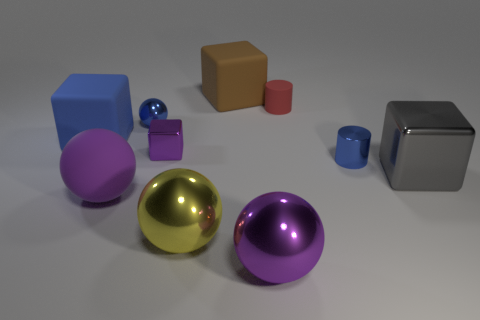What material is the blue cube?
Your response must be concise. Rubber. What number of objects are either small purple metal blocks or large balls?
Ensure brevity in your answer.  4. How big is the rubber cube that is left of the brown rubber block?
Make the answer very short. Large. What number of other objects are the same material as the small blue cylinder?
Offer a terse response. 5. There is a big purple sphere right of the matte ball; is there a large rubber cube that is behind it?
Your answer should be compact. Yes. What color is the other metal object that is the same shape as the large gray thing?
Your answer should be very brief. Purple. What size is the yellow metal object?
Make the answer very short. Large. Are there fewer big gray metallic cubes to the left of the big brown cube than large purple balls?
Your response must be concise. Yes. Are the small red cylinder and the purple sphere on the left side of the big brown rubber object made of the same material?
Give a very brief answer. Yes. Are there any purple metallic spheres that are in front of the ball behind the large gray cube behind the large yellow sphere?
Your answer should be very brief. Yes. 